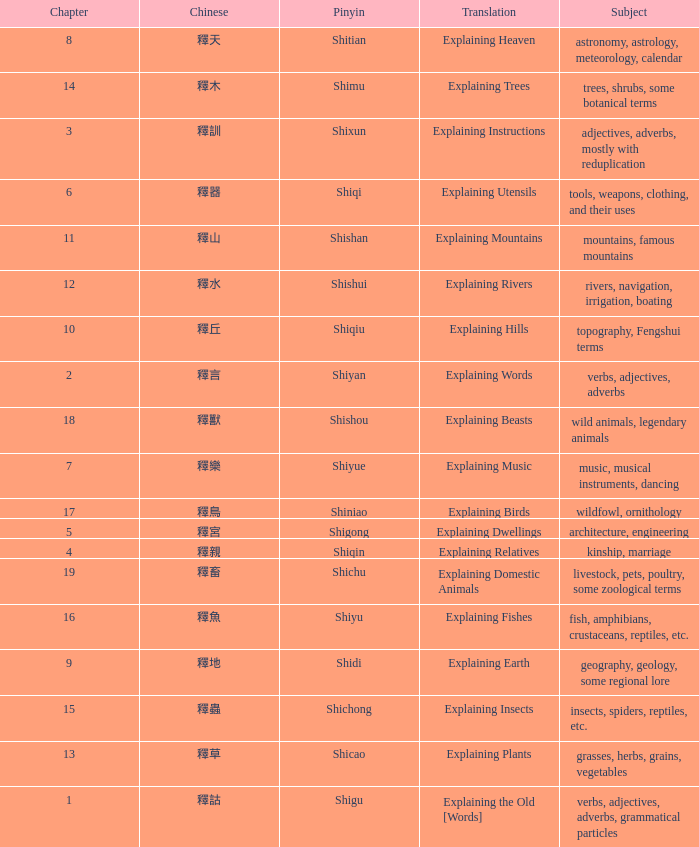Name the total number of chapter for chinese of 釋宮 1.0. 